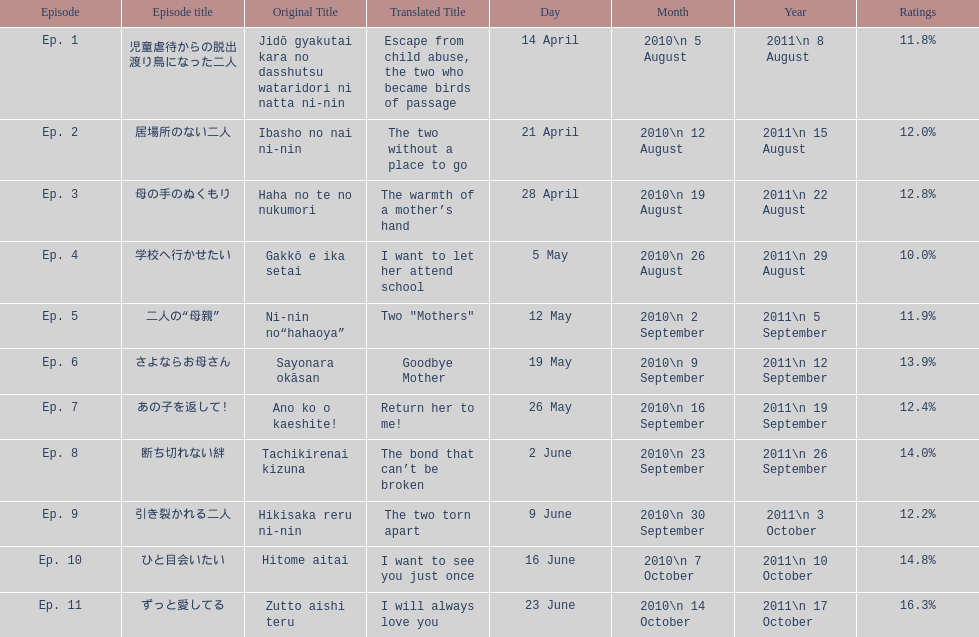What episode number was the only episode to have over 16% of ratings? 11. 